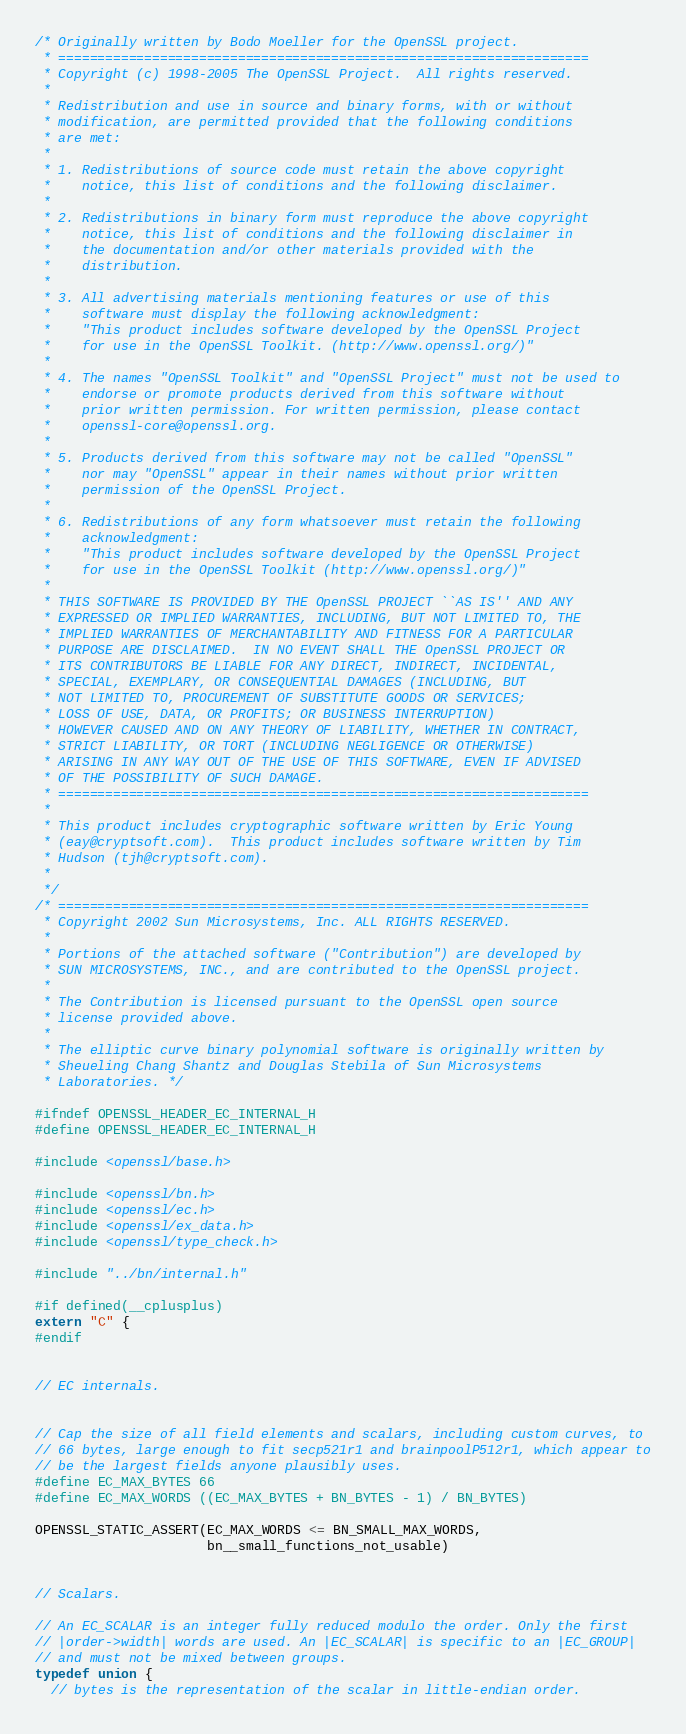<code> <loc_0><loc_0><loc_500><loc_500><_C_>/* Originally written by Bodo Moeller for the OpenSSL project.
 * ====================================================================
 * Copyright (c) 1998-2005 The OpenSSL Project.  All rights reserved.
 *
 * Redistribution and use in source and binary forms, with or without
 * modification, are permitted provided that the following conditions
 * are met:
 *
 * 1. Redistributions of source code must retain the above copyright
 *    notice, this list of conditions and the following disclaimer.
 *
 * 2. Redistributions in binary form must reproduce the above copyright
 *    notice, this list of conditions and the following disclaimer in
 *    the documentation and/or other materials provided with the
 *    distribution.
 *
 * 3. All advertising materials mentioning features or use of this
 *    software must display the following acknowledgment:
 *    "This product includes software developed by the OpenSSL Project
 *    for use in the OpenSSL Toolkit. (http://www.openssl.org/)"
 *
 * 4. The names "OpenSSL Toolkit" and "OpenSSL Project" must not be used to
 *    endorse or promote products derived from this software without
 *    prior written permission. For written permission, please contact
 *    openssl-core@openssl.org.
 *
 * 5. Products derived from this software may not be called "OpenSSL"
 *    nor may "OpenSSL" appear in their names without prior written
 *    permission of the OpenSSL Project.
 *
 * 6. Redistributions of any form whatsoever must retain the following
 *    acknowledgment:
 *    "This product includes software developed by the OpenSSL Project
 *    for use in the OpenSSL Toolkit (http://www.openssl.org/)"
 *
 * THIS SOFTWARE IS PROVIDED BY THE OpenSSL PROJECT ``AS IS'' AND ANY
 * EXPRESSED OR IMPLIED WARRANTIES, INCLUDING, BUT NOT LIMITED TO, THE
 * IMPLIED WARRANTIES OF MERCHANTABILITY AND FITNESS FOR A PARTICULAR
 * PURPOSE ARE DISCLAIMED.  IN NO EVENT SHALL THE OpenSSL PROJECT OR
 * ITS CONTRIBUTORS BE LIABLE FOR ANY DIRECT, INDIRECT, INCIDENTAL,
 * SPECIAL, EXEMPLARY, OR CONSEQUENTIAL DAMAGES (INCLUDING, BUT
 * NOT LIMITED TO, PROCUREMENT OF SUBSTITUTE GOODS OR SERVICES;
 * LOSS OF USE, DATA, OR PROFITS; OR BUSINESS INTERRUPTION)
 * HOWEVER CAUSED AND ON ANY THEORY OF LIABILITY, WHETHER IN CONTRACT,
 * STRICT LIABILITY, OR TORT (INCLUDING NEGLIGENCE OR OTHERWISE)
 * ARISING IN ANY WAY OUT OF THE USE OF THIS SOFTWARE, EVEN IF ADVISED
 * OF THE POSSIBILITY OF SUCH DAMAGE.
 * ====================================================================
 *
 * This product includes cryptographic software written by Eric Young
 * (eay@cryptsoft.com).  This product includes software written by Tim
 * Hudson (tjh@cryptsoft.com).
 *
 */
/* ====================================================================
 * Copyright 2002 Sun Microsystems, Inc. ALL RIGHTS RESERVED.
 *
 * Portions of the attached software ("Contribution") are developed by
 * SUN MICROSYSTEMS, INC., and are contributed to the OpenSSL project.
 *
 * The Contribution is licensed pursuant to the OpenSSL open source
 * license provided above.
 *
 * The elliptic curve binary polynomial software is originally written by
 * Sheueling Chang Shantz and Douglas Stebila of Sun Microsystems
 * Laboratories. */

#ifndef OPENSSL_HEADER_EC_INTERNAL_H
#define OPENSSL_HEADER_EC_INTERNAL_H

#include <openssl/base.h>

#include <openssl/bn.h>
#include <openssl/ec.h>
#include <openssl/ex_data.h>
#include <openssl/type_check.h>

#include "../bn/internal.h"

#if defined(__cplusplus)
extern "C" {
#endif


// EC internals.


// Cap the size of all field elements and scalars, including custom curves, to
// 66 bytes, large enough to fit secp521r1 and brainpoolP512r1, which appear to
// be the largest fields anyone plausibly uses.
#define EC_MAX_BYTES 66
#define EC_MAX_WORDS ((EC_MAX_BYTES + BN_BYTES - 1) / BN_BYTES)

OPENSSL_STATIC_ASSERT(EC_MAX_WORDS <= BN_SMALL_MAX_WORDS,
                      bn__small_functions_not_usable)


// Scalars.

// An EC_SCALAR is an integer fully reduced modulo the order. Only the first
// |order->width| words are used. An |EC_SCALAR| is specific to an |EC_GROUP|
// and must not be mixed between groups.
typedef union {
  // bytes is the representation of the scalar in little-endian order.</code> 